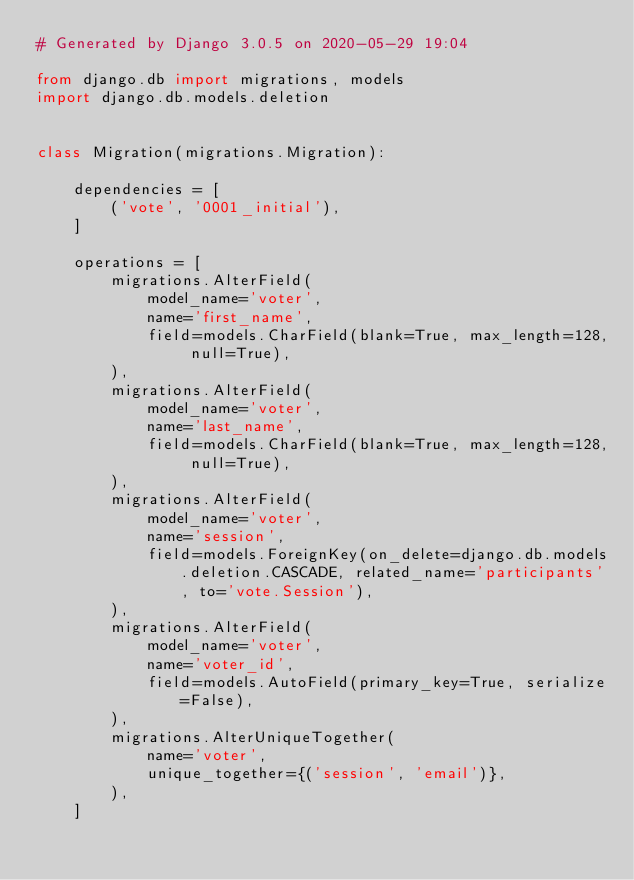Convert code to text. <code><loc_0><loc_0><loc_500><loc_500><_Python_># Generated by Django 3.0.5 on 2020-05-29 19:04

from django.db import migrations, models
import django.db.models.deletion


class Migration(migrations.Migration):

    dependencies = [
        ('vote', '0001_initial'),
    ]

    operations = [
        migrations.AlterField(
            model_name='voter',
            name='first_name',
            field=models.CharField(blank=True, max_length=128, null=True),
        ),
        migrations.AlterField(
            model_name='voter',
            name='last_name',
            field=models.CharField(blank=True, max_length=128, null=True),
        ),
        migrations.AlterField(
            model_name='voter',
            name='session',
            field=models.ForeignKey(on_delete=django.db.models.deletion.CASCADE, related_name='participants', to='vote.Session'),
        ),
        migrations.AlterField(
            model_name='voter',
            name='voter_id',
            field=models.AutoField(primary_key=True, serialize=False),
        ),
        migrations.AlterUniqueTogether(
            name='voter',
            unique_together={('session', 'email')},
        ),
    ]
</code> 